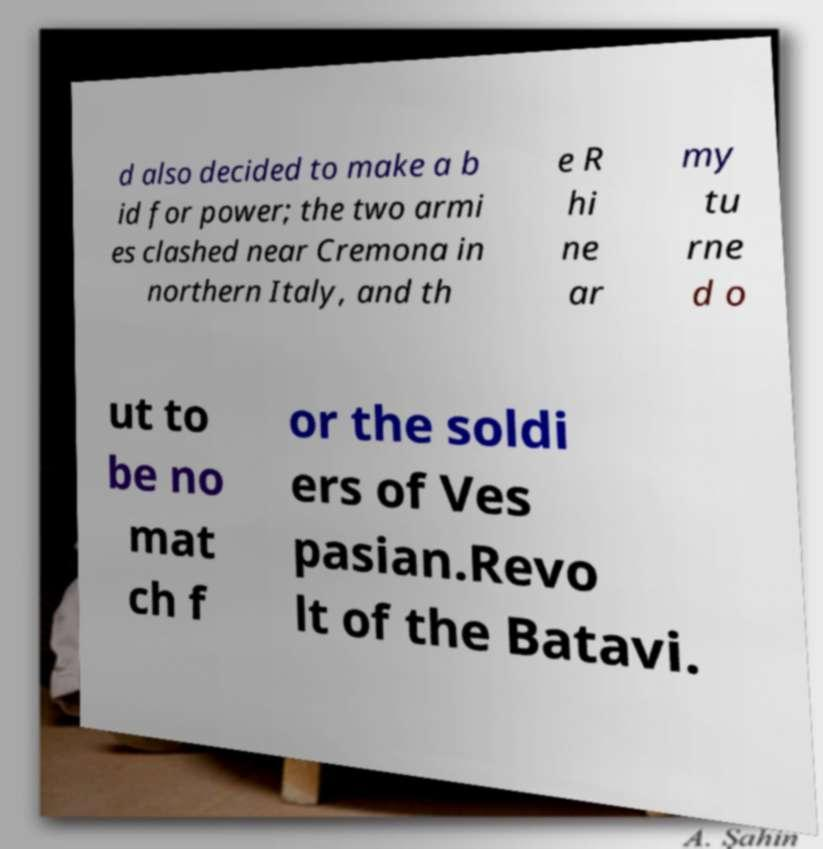Could you assist in decoding the text presented in this image and type it out clearly? d also decided to make a b id for power; the two armi es clashed near Cremona in northern Italy, and th e R hi ne ar my tu rne d o ut to be no mat ch f or the soldi ers of Ves pasian.Revo lt of the Batavi. 